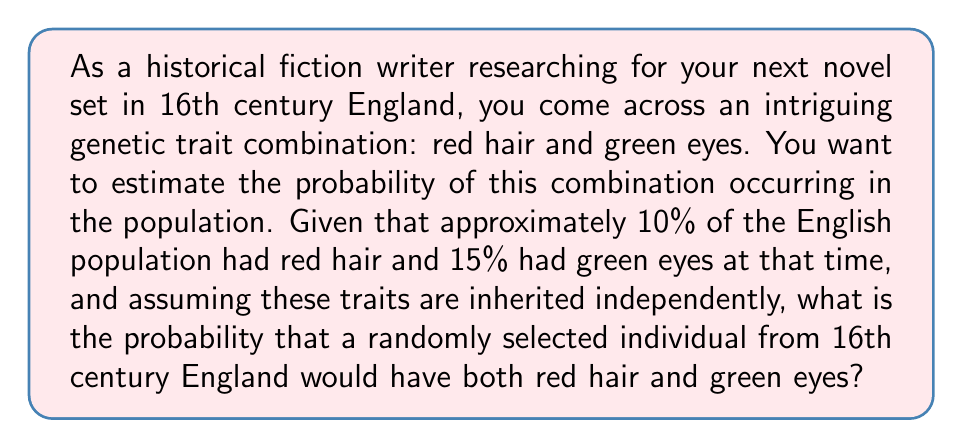Give your solution to this math problem. To solve this problem, we need to use the concept of independent events in probability theory. Since we're assuming that the inheritance of red hair and green eyes are independent events, we can multiply their individual probabilities to find the probability of both occurring together.

Let's define our events:
R: The event of having red hair (probability = 0.10 or 10%)
G: The event of having green eyes (probability = 0.15 or 15%)

We want to find P(R and G), the probability of both events occurring together.

For independent events, the probability of both occurring is the product of their individual probabilities:

$$ P(R \text{ and } G) = P(R) \times P(G) $$

Substituting the given probabilities:

$$ P(R \text{ and } G) = 0.10 \times 0.15 $$

Calculating:

$$ P(R \text{ and } G) = 0.015 $$

To convert this to a percentage, we multiply by 100:

$$ 0.015 \times 100 = 1.5\% $$

Therefore, the probability of a randomly selected individual from 16th century England having both red hair and green eyes is 1.5% or 0.015.
Answer: 1.5% or 0.015 